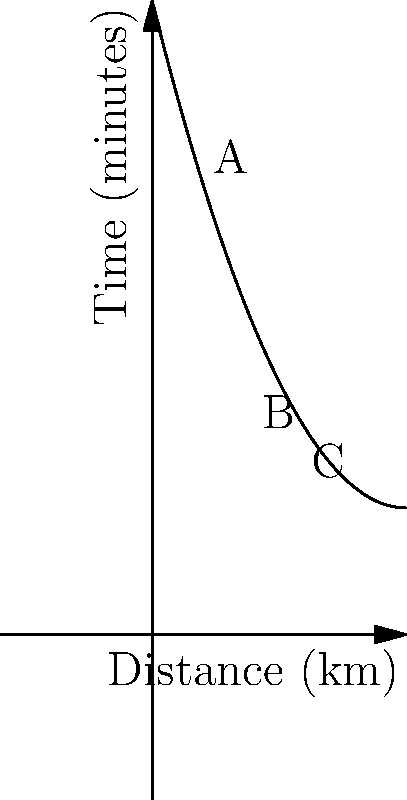You're planning a heist to steal high-tech gadgets from three locations: A, B, and C. The quadratic function $T(d) = 0.2d^2 - 4d + 25$ represents the time (in minutes) it takes to travel a distance $d$ (in kilometers) between locations. Given that A is 2 km from your starting point, B is 5 km, and C is 8 km, what is the optimal order to visit these locations to minimize total travel time? To solve this problem, we need to calculate the time for each possible route and compare them:

1. Calculate time for each distance:
   For A (2 km): $T(2) = 0.2(2)^2 - 4(2) + 25 = 17$ minutes
   For B (5 km): $T(5) = 0.2(5)^2 - 4(5) + 25 = 10$ minutes
   For C (8 km): $T(8) = 0.2(8)^2 - 4(8) + 25 = 17$ minutes

2. Calculate total time for each possible route:
   Route ABC: $T(2) + T(3) + T(3) = 17 + 13 + 13 = 43$ minutes
   Route ACB: $T(2) + T(6) + T(3) = 17 + 13 + 13 = 43$ minutes
   Route BAC: $T(5) + T(3) + T(3) = 10 + 13 + 13 = 36$ minutes
   Route BCA: $T(5) + T(3) + T(6) = 10 + 13 + 13 = 36$ minutes
   Route CAB: $T(8) + T(6) + T(3) = 17 + 13 + 13 = 43$ minutes
   Route CBA: $T(8) + T(3) + T(3) = 17 + 13 + 13 = 43$ minutes

3. Compare the total times:
   The routes BAC and BCA both have the minimum total time of 36 minutes.

4. Choose the optimal route:
   Since both BAC and BCA have the same total time, either can be chosen as the optimal route.
Answer: BAC or BCA 